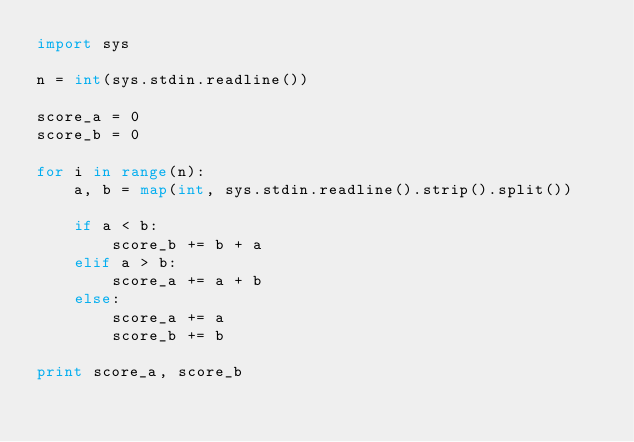Convert code to text. <code><loc_0><loc_0><loc_500><loc_500><_Python_>import sys

n = int(sys.stdin.readline())

score_a = 0
score_b = 0

for i in range(n):
    a, b = map(int, sys.stdin.readline().strip().split())
    
    if a < b:
        score_b += b + a
    elif a > b:
        score_a += a + b
    else:
        score_a += a
        score_b += b

print score_a, score_b</code> 